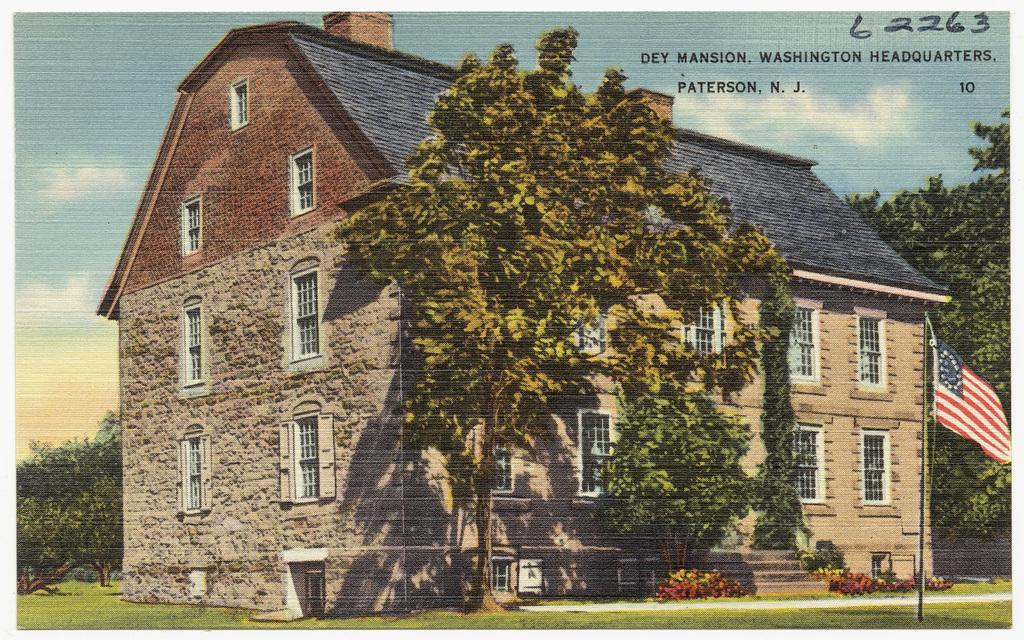What is the main subject of the image? The main subject of the image is a building. Are there any unique features of the building? Yes, there are trees inside the building. What can be seen on the right side of the building? There is a flag on the right side of the building. What type of canvas is being used to paint the card in the image? There is no canvas or card present in the image; it is a portrait of a building with trees inside and a flag on the right side. 